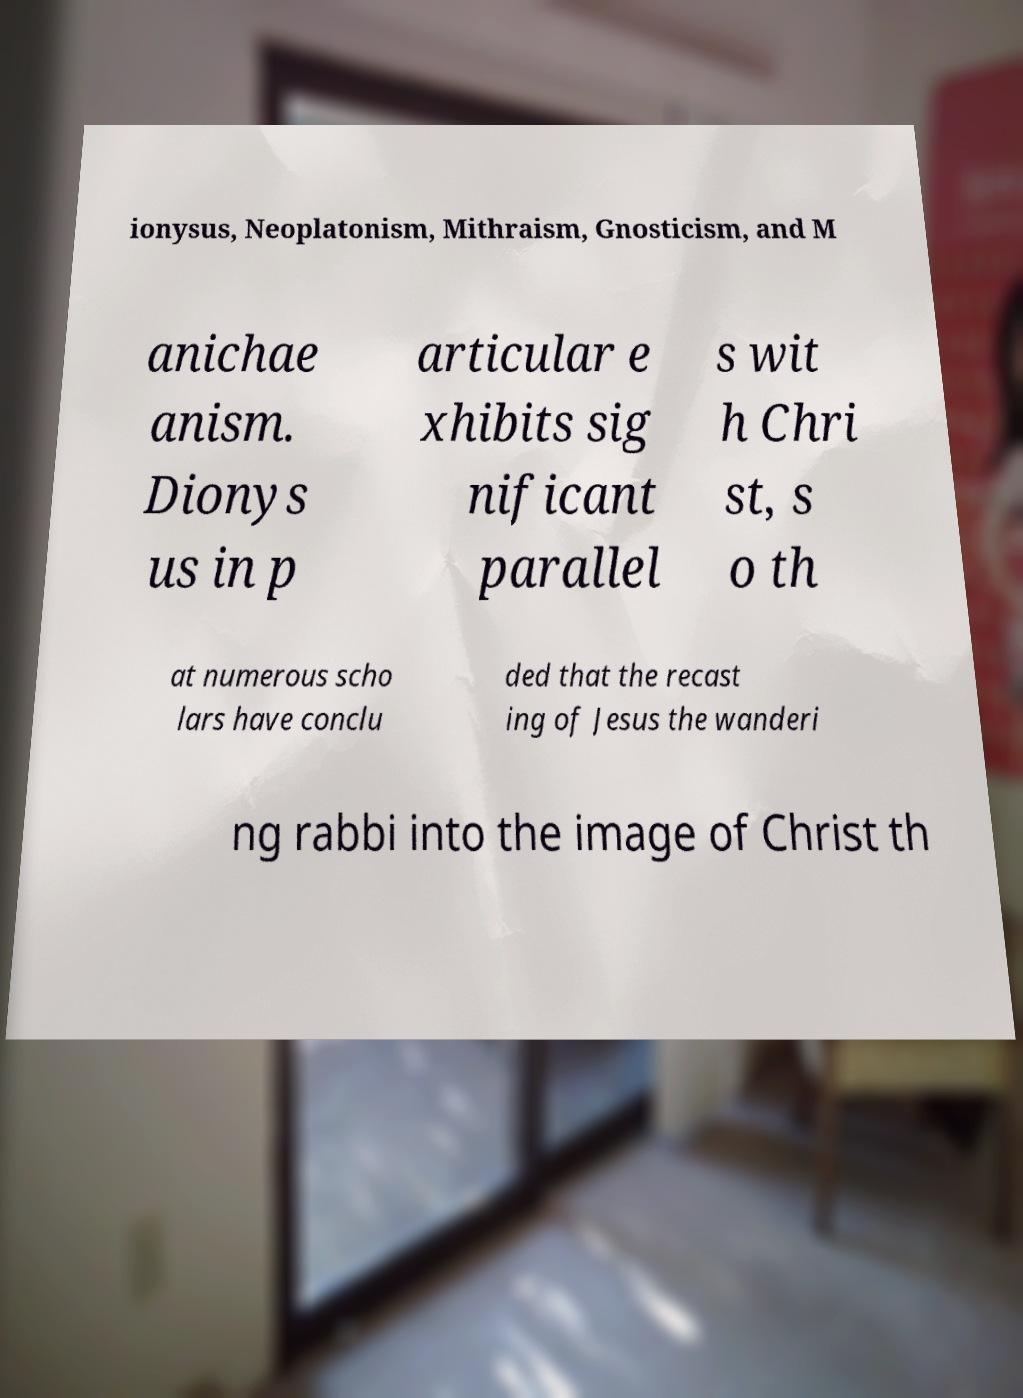Could you extract and type out the text from this image? ionysus, Neoplatonism, Mithraism, Gnosticism, and M anichae anism. Dionys us in p articular e xhibits sig nificant parallel s wit h Chri st, s o th at numerous scho lars have conclu ded that the recast ing of Jesus the wanderi ng rabbi into the image of Christ th 